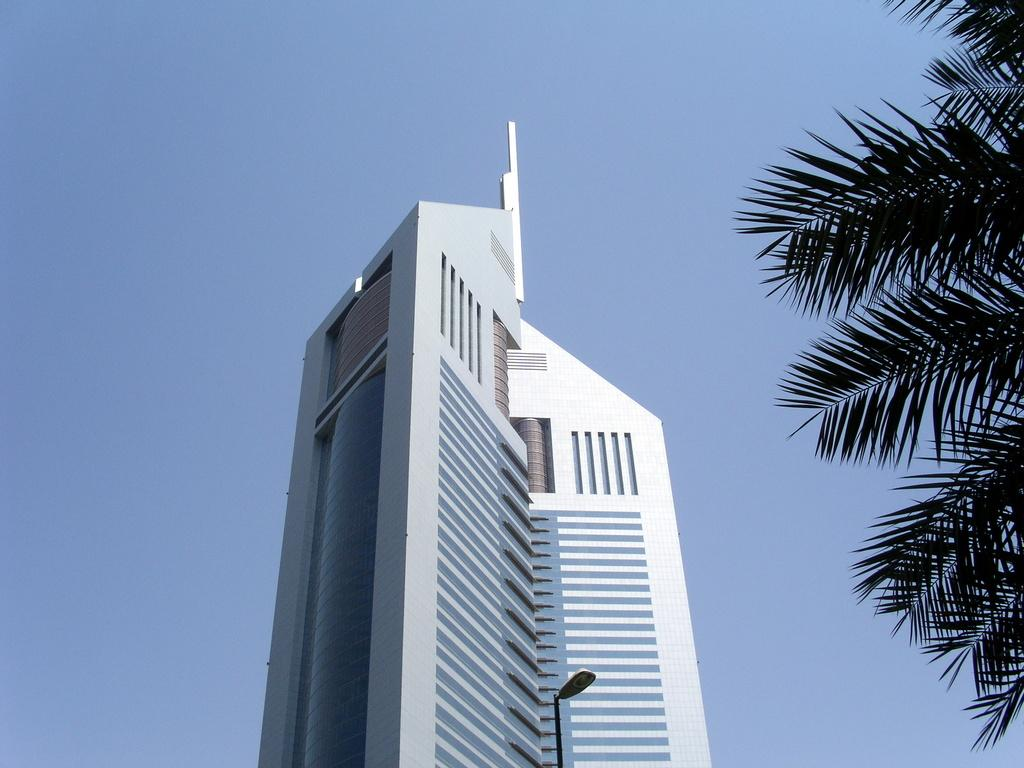What type of building is shown in the image? The image appears to depict a skyscraper. What type of object can be seen illuminating the street in the image? There is a street light visible in the image. What type of plant is present in the image? There is a tree with leaves in the image. What color is the sky in the image? The sky is blue in color. What type of zipper can be seen on the tree in the image? There is no zipper present on the tree in the image. What type of drawer can be seen in the sky in the image? There is no drawer present in the sky in the image. 